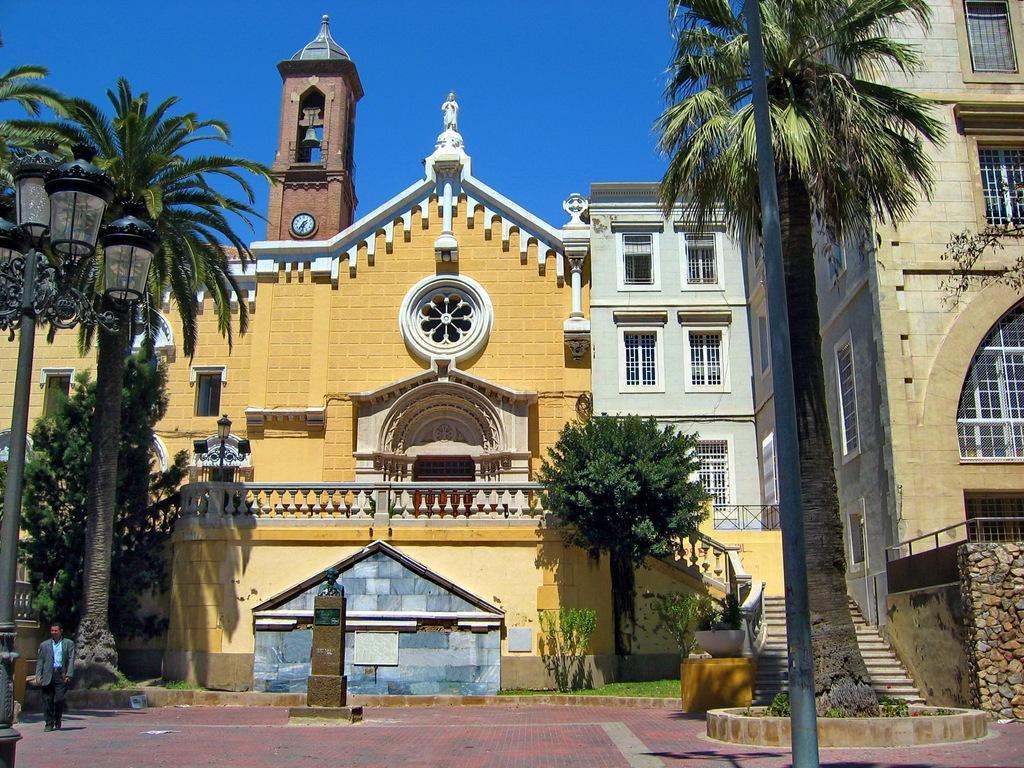Describe this image in one or two sentences. In this picture in the front there is pole. In the center there is a person standing and in the background there are buildings. In front of the building there are trees and on the left side in the front there is pole and there is a tower in the background behind the building which is in the center. 